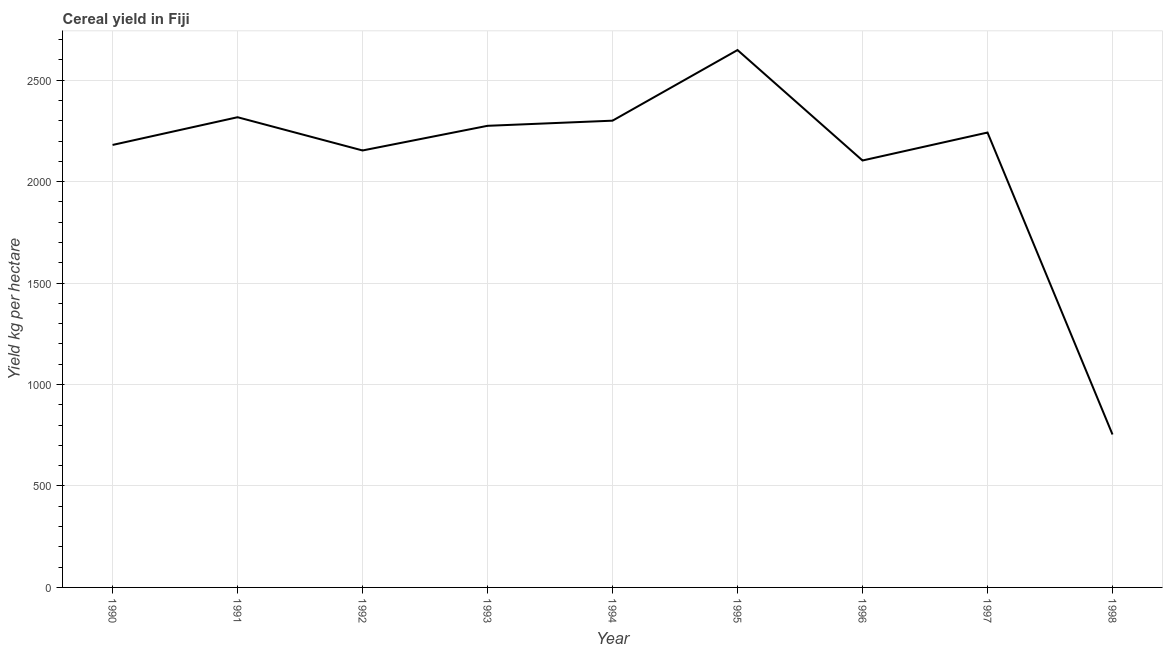What is the cereal yield in 1990?
Offer a very short reply. 2180.98. Across all years, what is the maximum cereal yield?
Your response must be concise. 2648.68. Across all years, what is the minimum cereal yield?
Your response must be concise. 753.82. In which year was the cereal yield maximum?
Keep it short and to the point. 1995. What is the sum of the cereal yield?
Ensure brevity in your answer.  1.90e+04. What is the difference between the cereal yield in 1995 and 1998?
Your response must be concise. 1894.87. What is the average cereal yield per year?
Give a very brief answer. 2108.56. What is the median cereal yield?
Make the answer very short. 2242.12. What is the ratio of the cereal yield in 1993 to that in 1994?
Your answer should be very brief. 0.99. Is the cereal yield in 1992 less than that in 1994?
Your answer should be compact. Yes. Is the difference between the cereal yield in 1991 and 1993 greater than the difference between any two years?
Your answer should be compact. No. What is the difference between the highest and the second highest cereal yield?
Provide a short and direct response. 331.12. What is the difference between the highest and the lowest cereal yield?
Keep it short and to the point. 1894.87. Does the cereal yield monotonically increase over the years?
Your response must be concise. No. How many lines are there?
Ensure brevity in your answer.  1. How many years are there in the graph?
Provide a succinct answer. 9. Does the graph contain any zero values?
Make the answer very short. No. Does the graph contain grids?
Give a very brief answer. Yes. What is the title of the graph?
Your response must be concise. Cereal yield in Fiji. What is the label or title of the Y-axis?
Give a very brief answer. Yield kg per hectare. What is the Yield kg per hectare in 1990?
Your answer should be compact. 2180.98. What is the Yield kg per hectare of 1991?
Make the answer very short. 2317.56. What is the Yield kg per hectare of 1992?
Your answer should be very brief. 2153.7. What is the Yield kg per hectare in 1993?
Offer a terse response. 2275.27. What is the Yield kg per hectare of 1994?
Your answer should be compact. 2300.6. What is the Yield kg per hectare in 1995?
Keep it short and to the point. 2648.68. What is the Yield kg per hectare in 1996?
Give a very brief answer. 2104.3. What is the Yield kg per hectare of 1997?
Keep it short and to the point. 2242.12. What is the Yield kg per hectare in 1998?
Provide a short and direct response. 753.82. What is the difference between the Yield kg per hectare in 1990 and 1991?
Ensure brevity in your answer.  -136.59. What is the difference between the Yield kg per hectare in 1990 and 1992?
Offer a very short reply. 27.27. What is the difference between the Yield kg per hectare in 1990 and 1993?
Provide a short and direct response. -94.3. What is the difference between the Yield kg per hectare in 1990 and 1994?
Ensure brevity in your answer.  -119.62. What is the difference between the Yield kg per hectare in 1990 and 1995?
Your answer should be very brief. -467.71. What is the difference between the Yield kg per hectare in 1990 and 1996?
Provide a succinct answer. 76.67. What is the difference between the Yield kg per hectare in 1990 and 1997?
Ensure brevity in your answer.  -61.14. What is the difference between the Yield kg per hectare in 1990 and 1998?
Offer a terse response. 1427.16. What is the difference between the Yield kg per hectare in 1991 and 1992?
Keep it short and to the point. 163.86. What is the difference between the Yield kg per hectare in 1991 and 1993?
Offer a terse response. 42.29. What is the difference between the Yield kg per hectare in 1991 and 1994?
Make the answer very short. 16.96. What is the difference between the Yield kg per hectare in 1991 and 1995?
Keep it short and to the point. -331.12. What is the difference between the Yield kg per hectare in 1991 and 1996?
Offer a terse response. 213.26. What is the difference between the Yield kg per hectare in 1991 and 1997?
Keep it short and to the point. 75.44. What is the difference between the Yield kg per hectare in 1991 and 1998?
Your answer should be compact. 1563.74. What is the difference between the Yield kg per hectare in 1992 and 1993?
Offer a terse response. -121.57. What is the difference between the Yield kg per hectare in 1992 and 1994?
Provide a succinct answer. -146.89. What is the difference between the Yield kg per hectare in 1992 and 1995?
Ensure brevity in your answer.  -494.98. What is the difference between the Yield kg per hectare in 1992 and 1996?
Provide a short and direct response. 49.4. What is the difference between the Yield kg per hectare in 1992 and 1997?
Ensure brevity in your answer.  -88.42. What is the difference between the Yield kg per hectare in 1992 and 1998?
Offer a very short reply. 1399.89. What is the difference between the Yield kg per hectare in 1993 and 1994?
Your response must be concise. -25.33. What is the difference between the Yield kg per hectare in 1993 and 1995?
Ensure brevity in your answer.  -373.41. What is the difference between the Yield kg per hectare in 1993 and 1996?
Offer a very short reply. 170.97. What is the difference between the Yield kg per hectare in 1993 and 1997?
Provide a short and direct response. 33.15. What is the difference between the Yield kg per hectare in 1993 and 1998?
Offer a very short reply. 1521.45. What is the difference between the Yield kg per hectare in 1994 and 1995?
Your response must be concise. -348.08. What is the difference between the Yield kg per hectare in 1994 and 1996?
Provide a short and direct response. 196.29. What is the difference between the Yield kg per hectare in 1994 and 1997?
Ensure brevity in your answer.  58.48. What is the difference between the Yield kg per hectare in 1994 and 1998?
Your answer should be very brief. 1546.78. What is the difference between the Yield kg per hectare in 1995 and 1996?
Keep it short and to the point. 544.38. What is the difference between the Yield kg per hectare in 1995 and 1997?
Make the answer very short. 406.56. What is the difference between the Yield kg per hectare in 1995 and 1998?
Provide a short and direct response. 1894.87. What is the difference between the Yield kg per hectare in 1996 and 1997?
Ensure brevity in your answer.  -137.82. What is the difference between the Yield kg per hectare in 1996 and 1998?
Your response must be concise. 1350.49. What is the difference between the Yield kg per hectare in 1997 and 1998?
Provide a short and direct response. 1488.3. What is the ratio of the Yield kg per hectare in 1990 to that in 1991?
Your answer should be very brief. 0.94. What is the ratio of the Yield kg per hectare in 1990 to that in 1993?
Offer a terse response. 0.96. What is the ratio of the Yield kg per hectare in 1990 to that in 1994?
Your answer should be compact. 0.95. What is the ratio of the Yield kg per hectare in 1990 to that in 1995?
Offer a very short reply. 0.82. What is the ratio of the Yield kg per hectare in 1990 to that in 1996?
Ensure brevity in your answer.  1.04. What is the ratio of the Yield kg per hectare in 1990 to that in 1998?
Offer a terse response. 2.89. What is the ratio of the Yield kg per hectare in 1991 to that in 1992?
Give a very brief answer. 1.08. What is the ratio of the Yield kg per hectare in 1991 to that in 1993?
Keep it short and to the point. 1.02. What is the ratio of the Yield kg per hectare in 1991 to that in 1995?
Give a very brief answer. 0.88. What is the ratio of the Yield kg per hectare in 1991 to that in 1996?
Your answer should be compact. 1.1. What is the ratio of the Yield kg per hectare in 1991 to that in 1997?
Offer a terse response. 1.03. What is the ratio of the Yield kg per hectare in 1991 to that in 1998?
Offer a very short reply. 3.07. What is the ratio of the Yield kg per hectare in 1992 to that in 1993?
Ensure brevity in your answer.  0.95. What is the ratio of the Yield kg per hectare in 1992 to that in 1994?
Give a very brief answer. 0.94. What is the ratio of the Yield kg per hectare in 1992 to that in 1995?
Your answer should be compact. 0.81. What is the ratio of the Yield kg per hectare in 1992 to that in 1996?
Your response must be concise. 1.02. What is the ratio of the Yield kg per hectare in 1992 to that in 1998?
Make the answer very short. 2.86. What is the ratio of the Yield kg per hectare in 1993 to that in 1995?
Offer a terse response. 0.86. What is the ratio of the Yield kg per hectare in 1993 to that in 1996?
Your answer should be compact. 1.08. What is the ratio of the Yield kg per hectare in 1993 to that in 1997?
Your answer should be very brief. 1.01. What is the ratio of the Yield kg per hectare in 1993 to that in 1998?
Keep it short and to the point. 3.02. What is the ratio of the Yield kg per hectare in 1994 to that in 1995?
Provide a short and direct response. 0.87. What is the ratio of the Yield kg per hectare in 1994 to that in 1996?
Provide a succinct answer. 1.09. What is the ratio of the Yield kg per hectare in 1994 to that in 1997?
Your response must be concise. 1.03. What is the ratio of the Yield kg per hectare in 1994 to that in 1998?
Offer a very short reply. 3.05. What is the ratio of the Yield kg per hectare in 1995 to that in 1996?
Make the answer very short. 1.26. What is the ratio of the Yield kg per hectare in 1995 to that in 1997?
Provide a short and direct response. 1.18. What is the ratio of the Yield kg per hectare in 1995 to that in 1998?
Give a very brief answer. 3.51. What is the ratio of the Yield kg per hectare in 1996 to that in 1997?
Give a very brief answer. 0.94. What is the ratio of the Yield kg per hectare in 1996 to that in 1998?
Provide a short and direct response. 2.79. What is the ratio of the Yield kg per hectare in 1997 to that in 1998?
Offer a terse response. 2.97. 